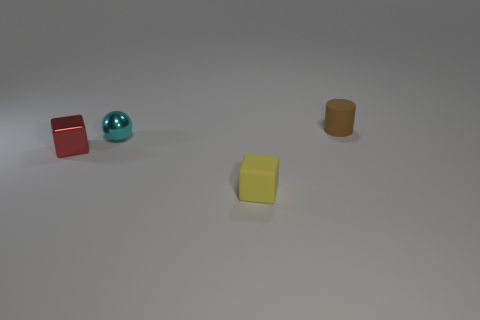Add 1 tiny objects. How many objects exist? 5 Subtract all balls. How many objects are left? 3 Add 2 tiny blue matte things. How many tiny blue matte things exist? 2 Subtract 0 yellow balls. How many objects are left? 4 Subtract all small yellow rubber things. Subtract all tiny purple cubes. How many objects are left? 3 Add 1 red blocks. How many red blocks are left? 2 